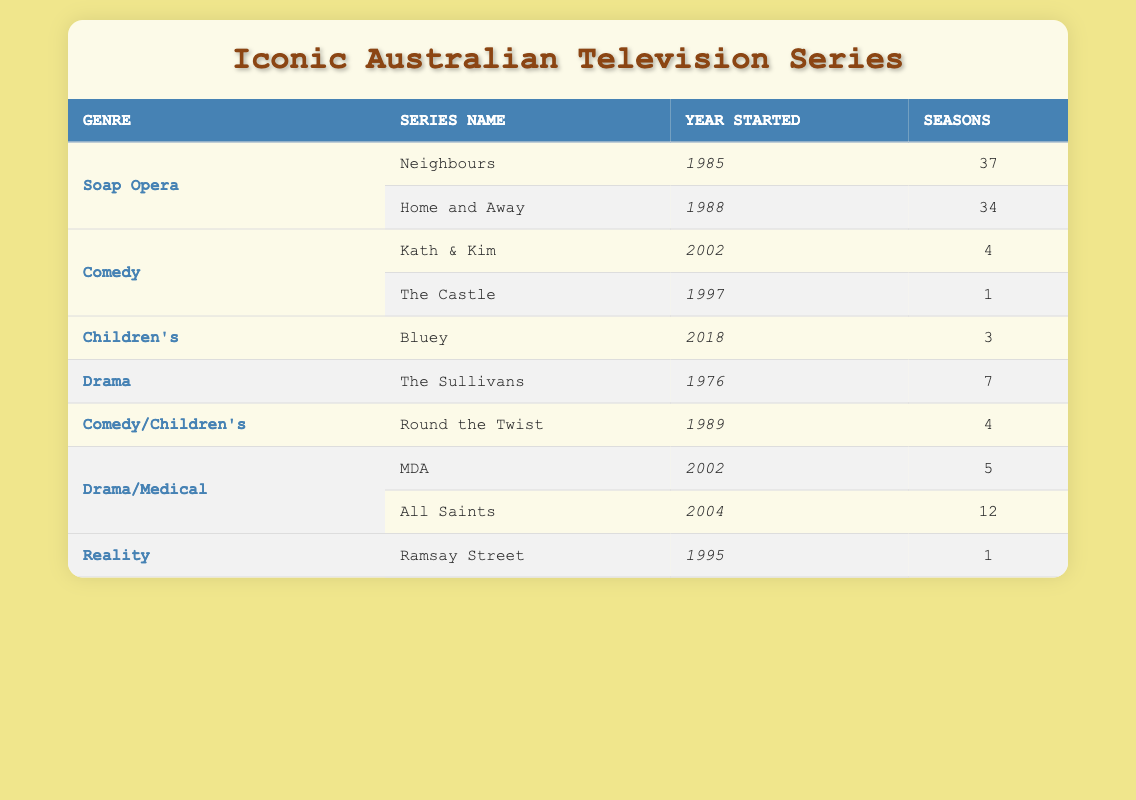What is the total number of seasons for all the Soap Opera series combined? To find the total number of seasons for the Soap Opera genre, we need to look at the rows corresponding to this genre. There are two series: Neighbours with 37 seasons and Home and Away with 34 seasons. Adding these together gives 37 + 34 = 71 seasons.
Answer: 71 What year did the series "All Saints" start? The table lists "All Saints" under the Drama/Medical genre and shows that it started in the year 2004.
Answer: 2004 Is "Kath & Kim" a children's show? "Kath & Kim" is classified under the Comedy genre, and there is a separate category for Children's shows (like "Bluey"). Therefore, it is not a children's show.
Answer: No How many more seasons does "Neighbours" have compared to "The Castle"? "Neighbours" has 37 seasons while "The Castle" has 1 season. The difference is calculated as 37 - 1 = 36 seasons.
Answer: 36 Which genre has the least number of seasons in total? To determine the genre with the least seasons, we need to sum the seasons for each genre: Soap Opera (71), Comedy (5), Children's (3), Drama (7), Comedy/Children's (4), Drama/Medical (17), Reality (1). The least total is found in the Reality genre with 1 season.
Answer: Reality How many Drama/Medical series are listed, and what are their names? From the table, there are two Drama/Medical series: MDA and All Saints. So, the count is 2.
Answer: 2 What is the average number of seasons for the Comedy genre series? The Comedy genre has two series: Kath & Kim with 4 seasons and The Castle with 1 season. We sum them up (4 + 1) to get 5 seasons and then divide by the number of series (2) to calculate the average: 5 / 2 = 2.5 seasons.
Answer: 2.5 Are there any children's shows that started before 2000? The only children's show listed is "Bluey," which started in 2018. Since there are no other children's shows in the table, the answer is No.
Answer: No What is the total number of seasons for all of the listed series? To find the total seasons, we sum the seasons of all series: 37 (Neighbours) + 34 (Home and Away) + 4 (Kath & Kim) + 3 (Bluey) + 7 (The Sullivans) + 4 (Round the Twist) + 5 (MDA) + 12 (All Saints) + 1 (Ramsay Street) = 107 seasons total.
Answer: 107 